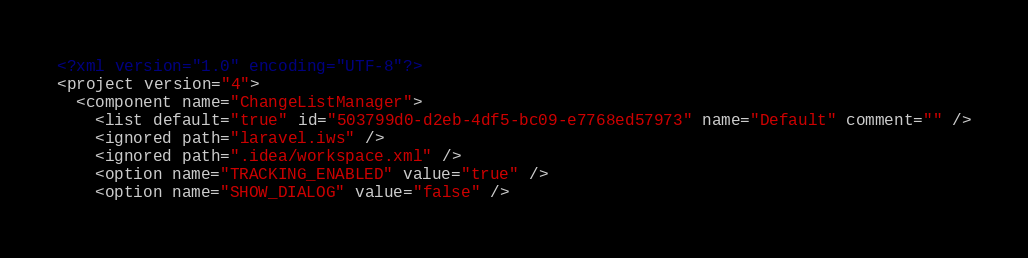Convert code to text. <code><loc_0><loc_0><loc_500><loc_500><_XML_><?xml version="1.0" encoding="UTF-8"?>
<project version="4">
  <component name="ChangeListManager">
    <list default="true" id="503799d0-d2eb-4df5-bc09-e7768ed57973" name="Default" comment="" />
    <ignored path="laravel.iws" />
    <ignored path=".idea/workspace.xml" />
    <option name="TRACKING_ENABLED" value="true" />
    <option name="SHOW_DIALOG" value="false" /></code> 